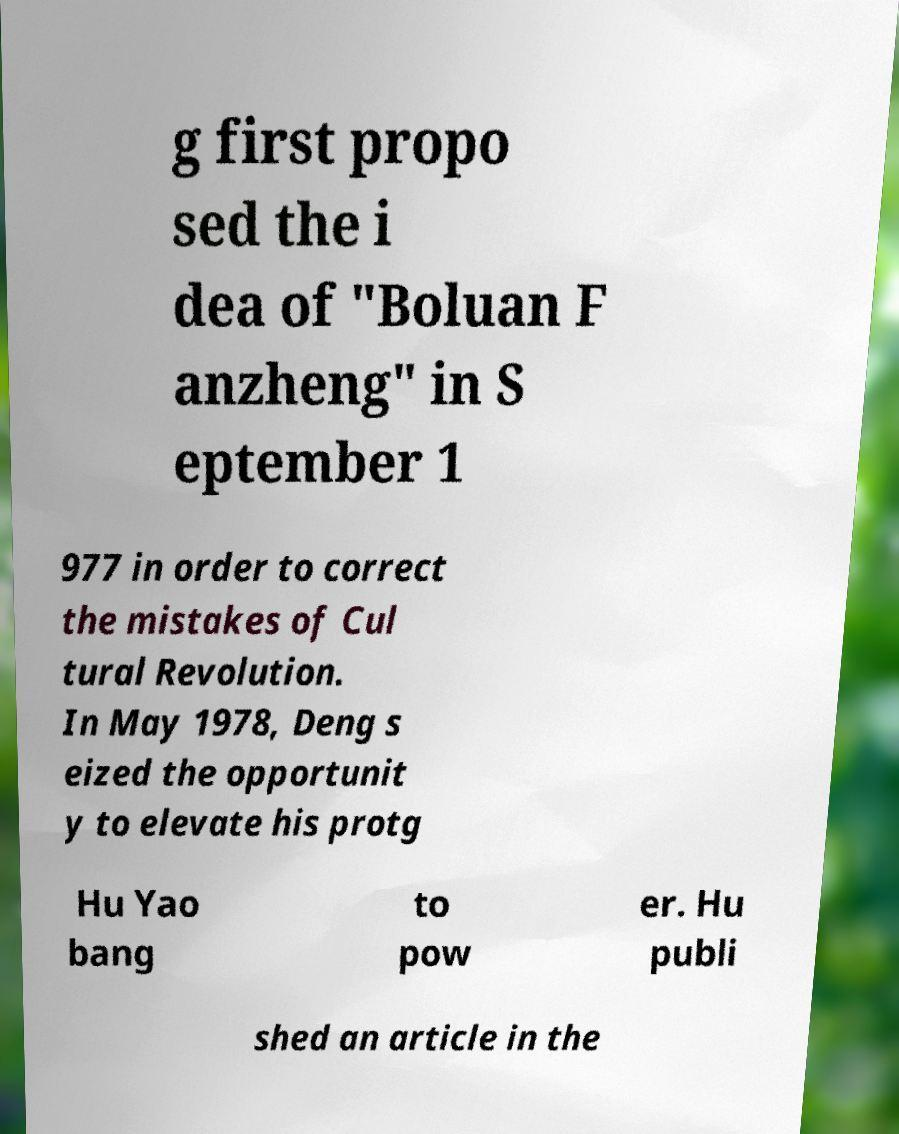Can you accurately transcribe the text from the provided image for me? g first propo sed the i dea of "Boluan F anzheng" in S eptember 1 977 in order to correct the mistakes of Cul tural Revolution. In May 1978, Deng s eized the opportunit y to elevate his protg Hu Yao bang to pow er. Hu publi shed an article in the 